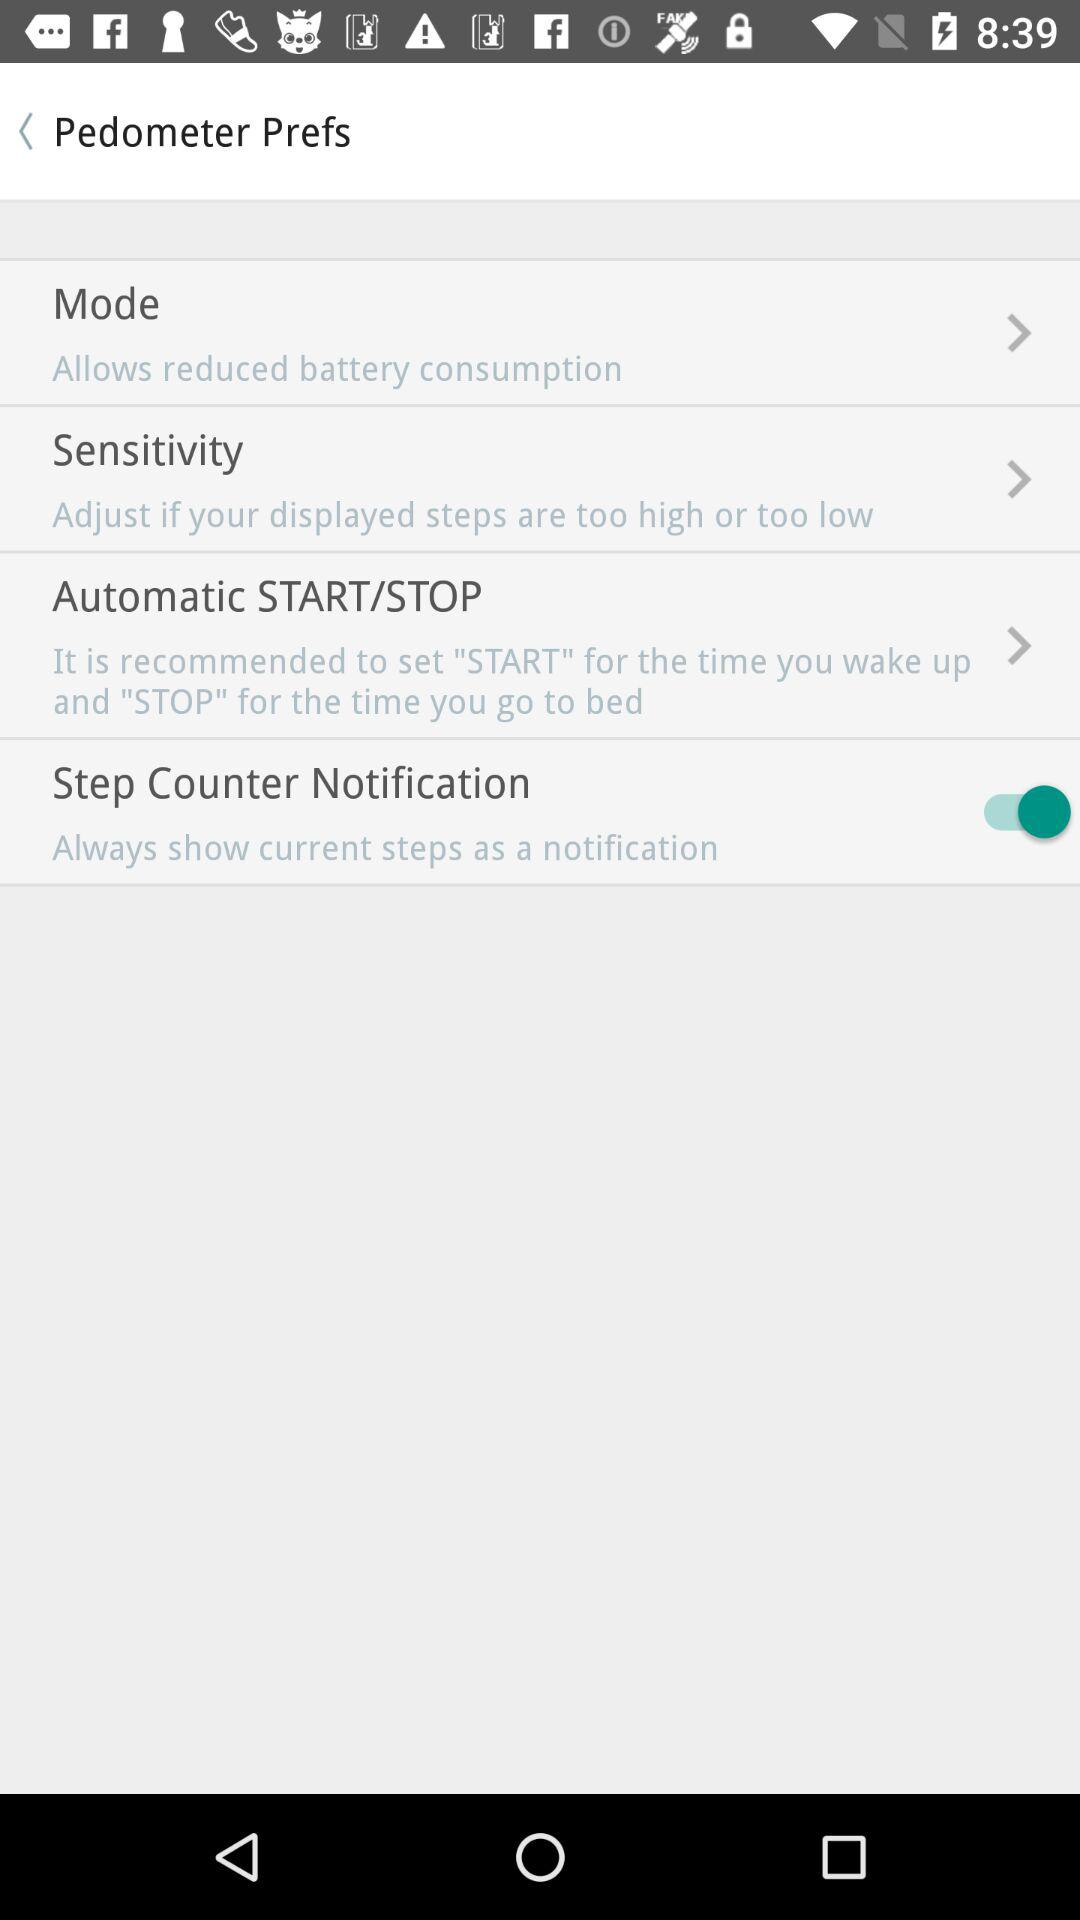What is the description of "Mode"? The description is "Allows reduced battery consumption". 